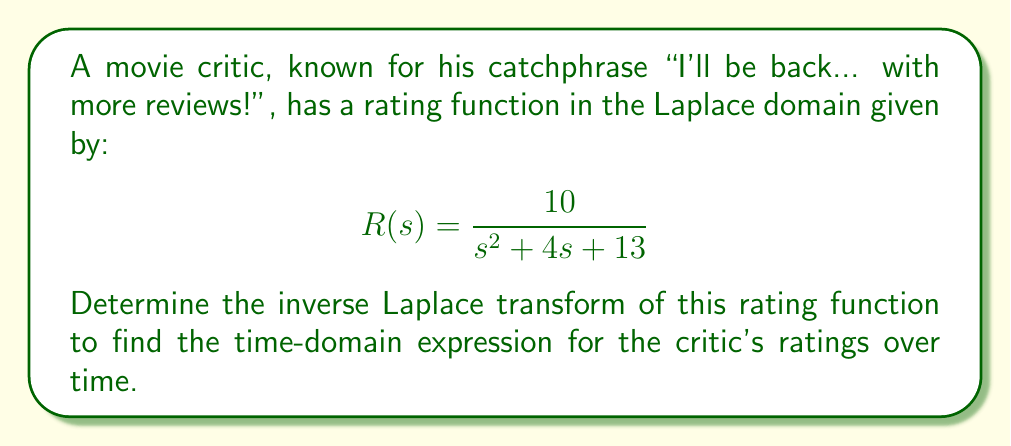What is the answer to this math problem? To find the inverse Laplace transform, we need to recognize the standard form and use the corresponding inverse transform. The given function is in the form:

$$\frac{A}{s^2 + 2as + b^2}$$

where $A = 10$, $2a = 4$ (so $a = 2$), and $b^2 = 13$.

The inverse Laplace transform of this form is:

$$\frac{A}{b} e^{-at} \sin(bt)$$

We need to find $b$:
$$b = \sqrt{13}$$

Now, let's substitute the values:

$$\frac{10}{\sqrt{13}} e^{-2t} \sin(\sqrt{13}t)$$

This can be simplified slightly:

$$\frac{10}{\sqrt{13}} e^{-2t} \sin(\sqrt{13}t)$$

As the critic might say, "Here's looking at you, inverse transform!"
Answer: $$r(t) = \frac{10}{\sqrt{13}} e^{-2t} \sin(\sqrt{13}t)$$ 